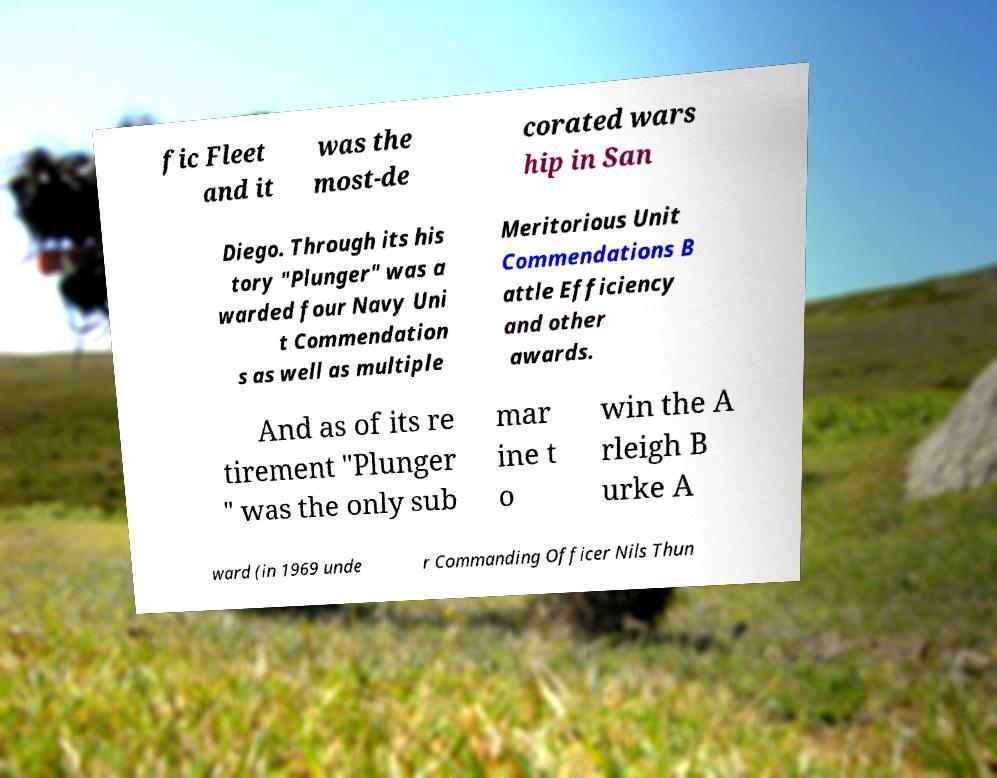Could you assist in decoding the text presented in this image and type it out clearly? fic Fleet and it was the most-de corated wars hip in San Diego. Through its his tory "Plunger" was a warded four Navy Uni t Commendation s as well as multiple Meritorious Unit Commendations B attle Efficiency and other awards. And as of its re tirement "Plunger " was the only sub mar ine t o win the A rleigh B urke A ward (in 1969 unde r Commanding Officer Nils Thun 